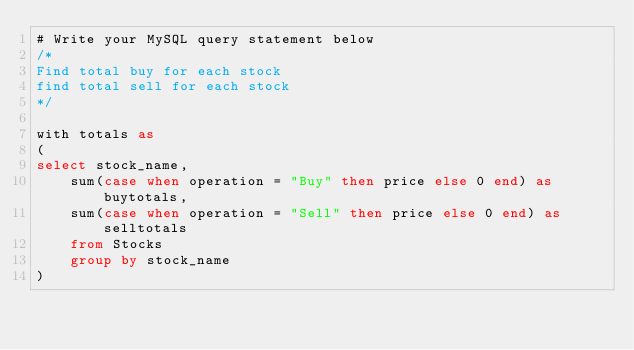<code> <loc_0><loc_0><loc_500><loc_500><_SQL_># Write your MySQL query statement below
/*
Find total buy for each stock
find total sell for each stock
*/

with totals as
(
select stock_name,
    sum(case when operation = "Buy" then price else 0 end) as buytotals,
    sum(case when operation = "Sell" then price else 0 end) as selltotals
    from Stocks
    group by stock_name
)
</code> 